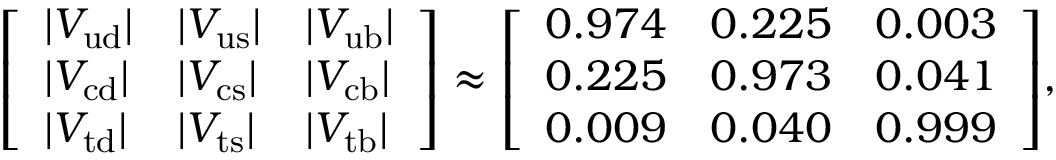Convert formula to latex. <formula><loc_0><loc_0><loc_500><loc_500>{ \left [ \begin{array} { l l l } { | V _ { u d } | } & { | V _ { u s } | } & { | V _ { u b } | } \\ { | V _ { c d } | } & { | V _ { c s } | } & { | V _ { c b } | } \\ { | V _ { t d } | } & { | V _ { t s } | } & { | V _ { t b } | } \end{array} \right ] } \approx { \left [ \begin{array} { l l l } { 0 . 9 7 4 } & { 0 . 2 2 5 } & { 0 . 0 0 3 } \\ { 0 . 2 2 5 } & { 0 . 9 7 3 } & { 0 . 0 4 1 } \\ { 0 . 0 0 9 } & { 0 . 0 4 0 } & { 0 . 9 9 9 } \end{array} \right ] } ,</formula> 